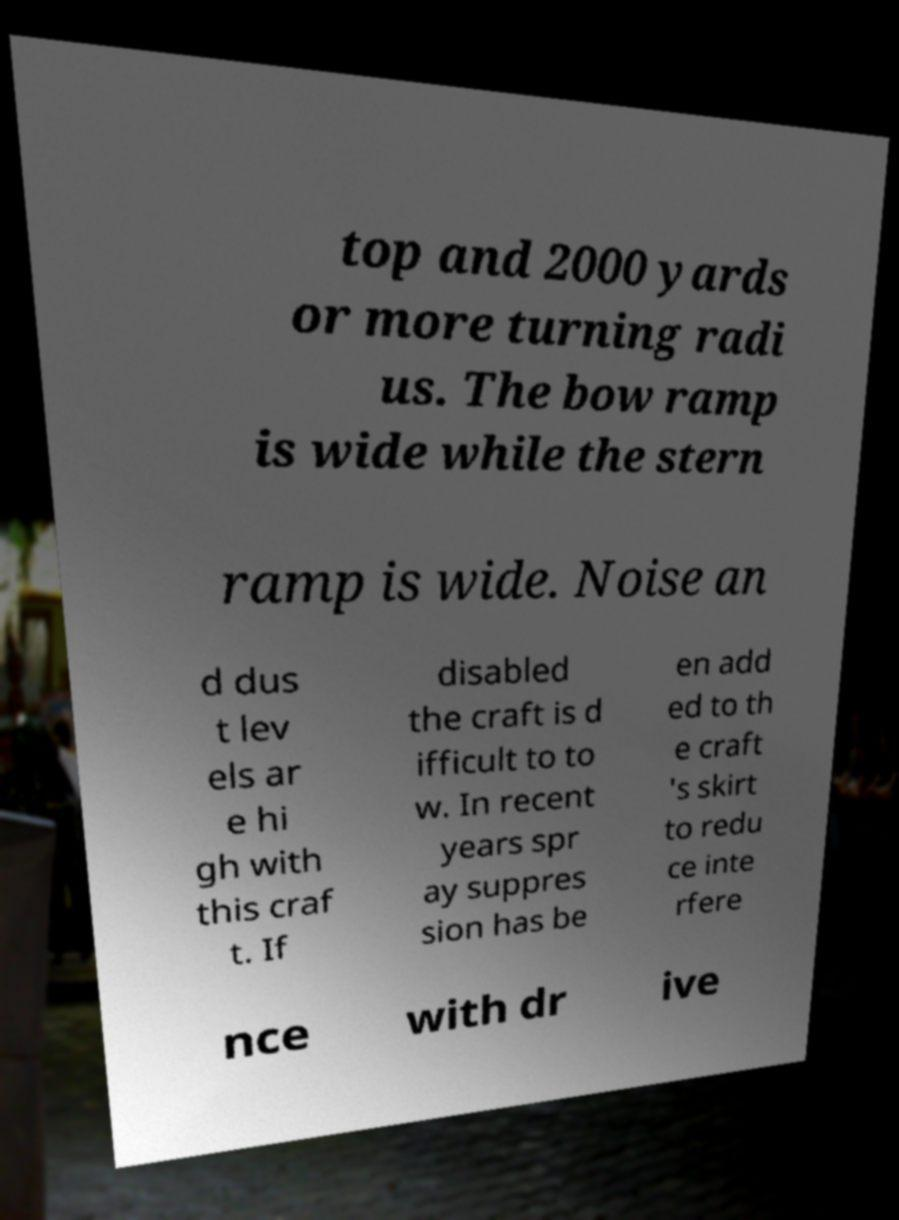Could you extract and type out the text from this image? top and 2000 yards or more turning radi us. The bow ramp is wide while the stern ramp is wide. Noise an d dus t lev els ar e hi gh with this craf t. If disabled the craft is d ifficult to to w. In recent years spr ay suppres sion has be en add ed to th e craft 's skirt to redu ce inte rfere nce with dr ive 